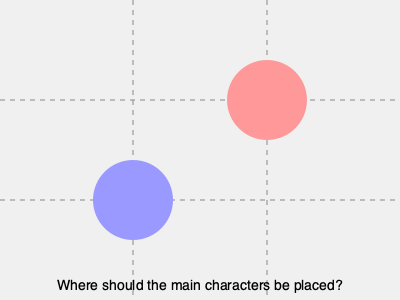In a romantic comedy scene, you want to create visual tension between two characters using the rule of thirds. Based on the diagram, which intersections should you place the main characters to achieve this effect? 1. The rule of thirds divides the frame into a 3x3 grid, creating four intersection points.
2. These intersection points are considered powerful areas for subject placement in composition.
3. To create visual tension, we want to place the characters at opposite intersections.
4. In the diagram, we see two circles representing the characters.
5. The red circle is at the top-right intersection (2/3 across, 1/3 down).
6. The blue circle is at the bottom-left intersection (1/3 across, 2/3 down).
7. This diagonal placement creates a visual connection between the characters while maintaining separation.
8. The space between them builds tension and anticipation, perfect for a romantic comedy scene.
9. This composition draws the viewer's eye back and forth between the characters, emphasizing their relationship.
Answer: Top-right and bottom-left intersections 